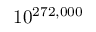Convert formula to latex. <formula><loc_0><loc_0><loc_500><loc_500>1 0 ^ { 2 7 2 , 0 0 0 }</formula> 